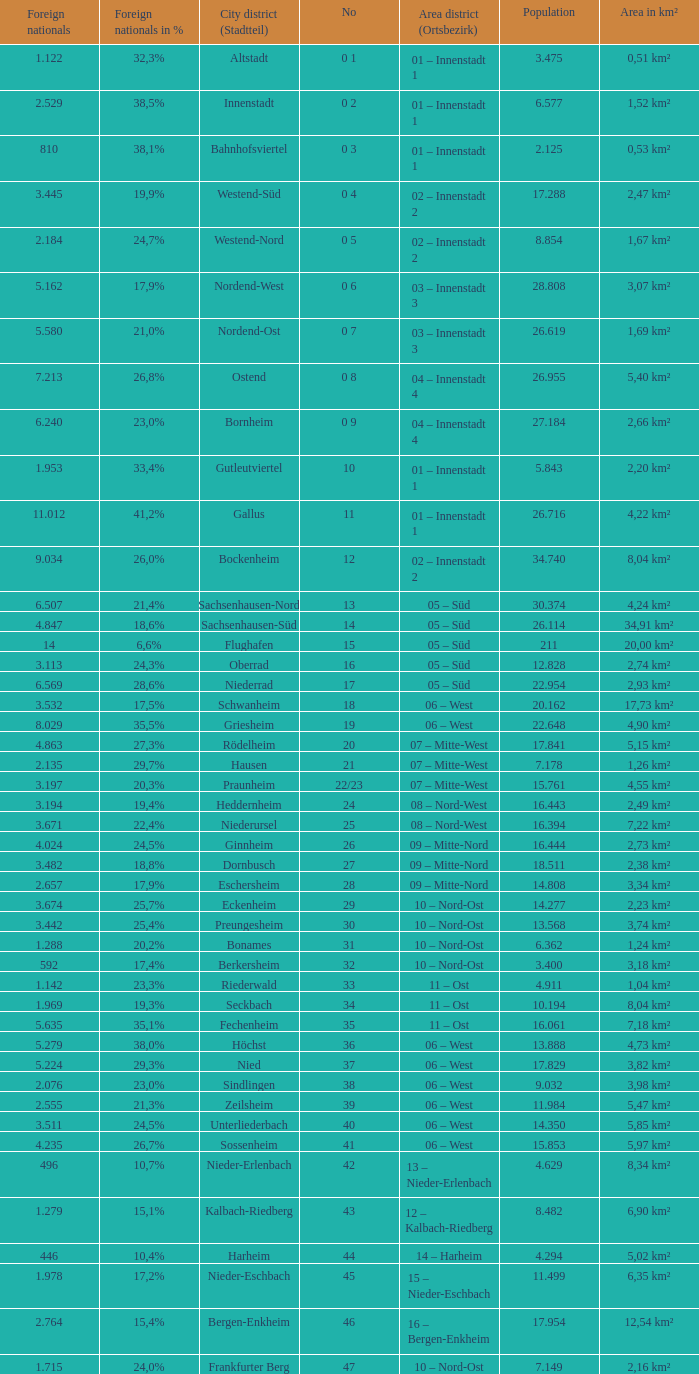How many foreigners in percentage terms had a population of 4.911? 1.0. 